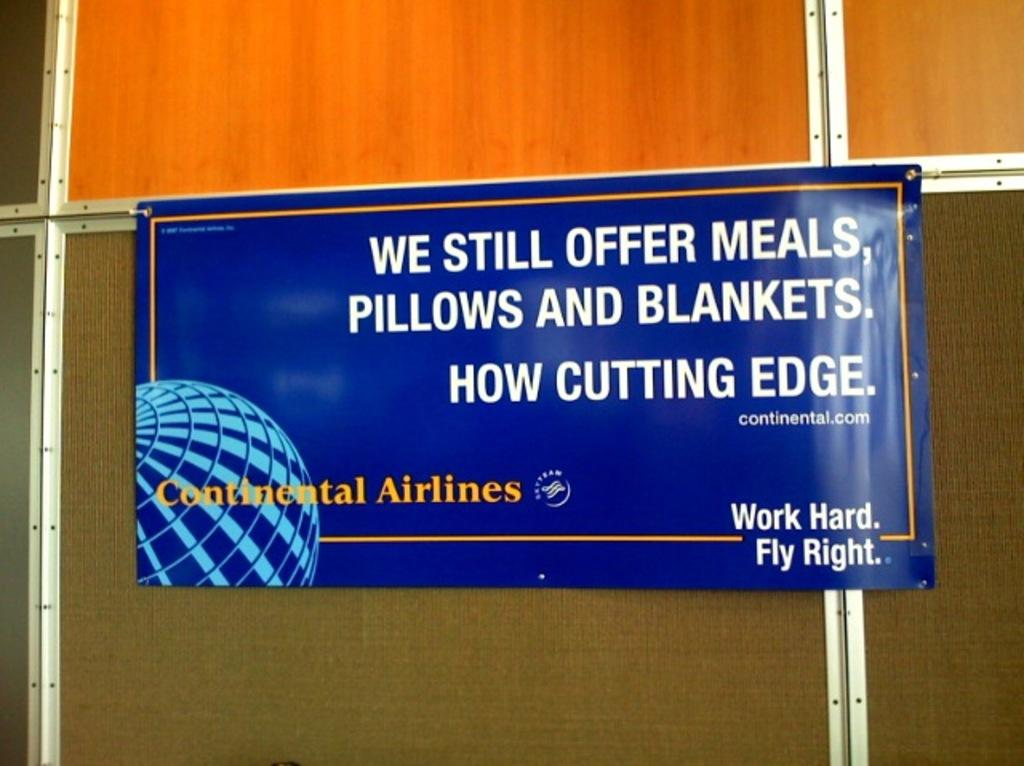What is hanging on the wooden wall in the image? There is a banner on the wooden wall in the image. What type of doctor is standing next to the banner in the image? There is no doctor present in the image; it only features a banner on a wooden wall. 